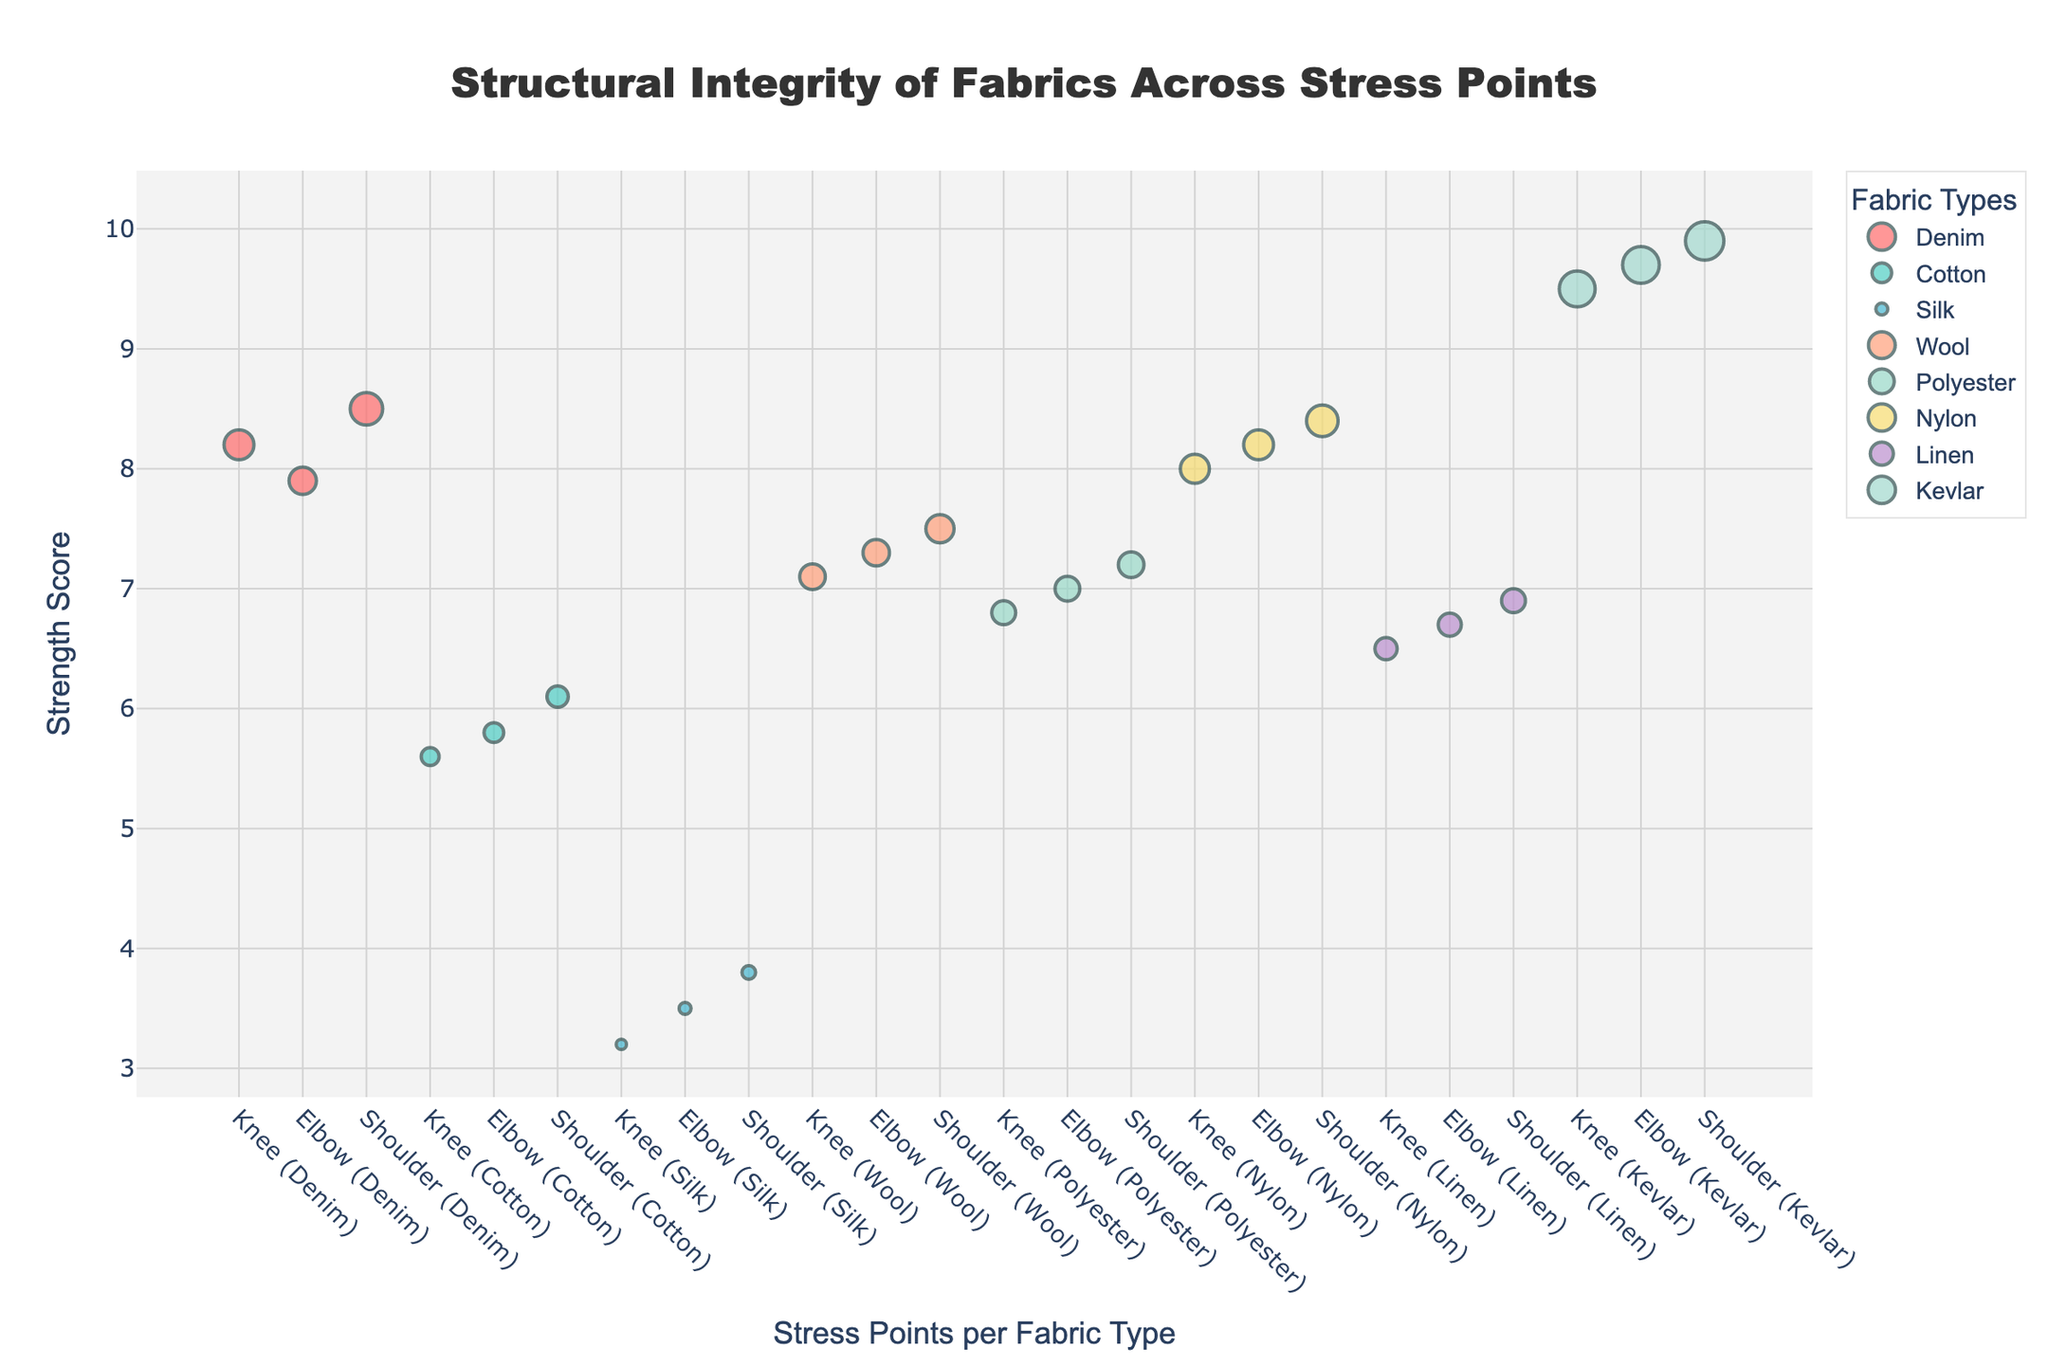How many different fabric types are displayed in the plot? There are individual traces (markers) for each fabric type shown in the plot legend. Counting them gives us the total number of fabric types.
Answer: 8 What is the fabric type with the highest significance value at the shoulder stress point? For each fabric's shoulder stress point, compare the corresponding significance values. Kevlar has the highest significance value of 4.5.
Answer: Kevlar Which fabric has the lowest strength score at the elbow stress point? Look at the elbow stress points for each fabric and compare their strength scores. Silk has the lowest at 3.5.
Answer: Silk What is the average strength score of Denim across all stress points? Sum the strength scores of Denim at knee (8.2), elbow (7.9), and shoulder (8.5), then divide by 3 (number of points). (8.2 + 7.9 + 8.5)/3 ≈ 8.20.
Answer: 8.20 Compare the strength scores between Denim and Nylon at the knee stress point. Which is higher? Check the strength scores of Denim (8.2) and Nylon (8.0) at the knee stress point, then compare them. Denim's strength score is slightly higher.
Answer: Denim Are the strength scores of Cotton significantly different from Polyester at the shoulder stress point? Examine the strength scores of Cotton (6.1) and Polyester (7.2) at the shoulder. A difference of 1.1 might be considered significant based on context.
Answer: Yes Which stress point generally displays the highest strength scores across all fabric types? Observe the y-axis values (strength scores) at knee, elbow, and shoulder stress points for all fabrics. The shoulder stress point generally has the highest scores.
Answer: Shoulder What is the difference in significance values between Wool and Linen at the knee stress point? Subtract the significance value of Linen (2.6) from that of Wool (3.0) at knee. 3.0 - 2.6 = 0.4.
Answer: 0.4 For which stress point does Kevlar show the greatest difference in strength score compared to Silk? Calculate the differences in strength scores between Kevlar and Silk for knee (9.5 - 3.2), elbow (9.7 - 3.5), and shoulder (9.9 - 3.8). The largest difference is at the shoulder (6.1).
Answer: Shoulder 